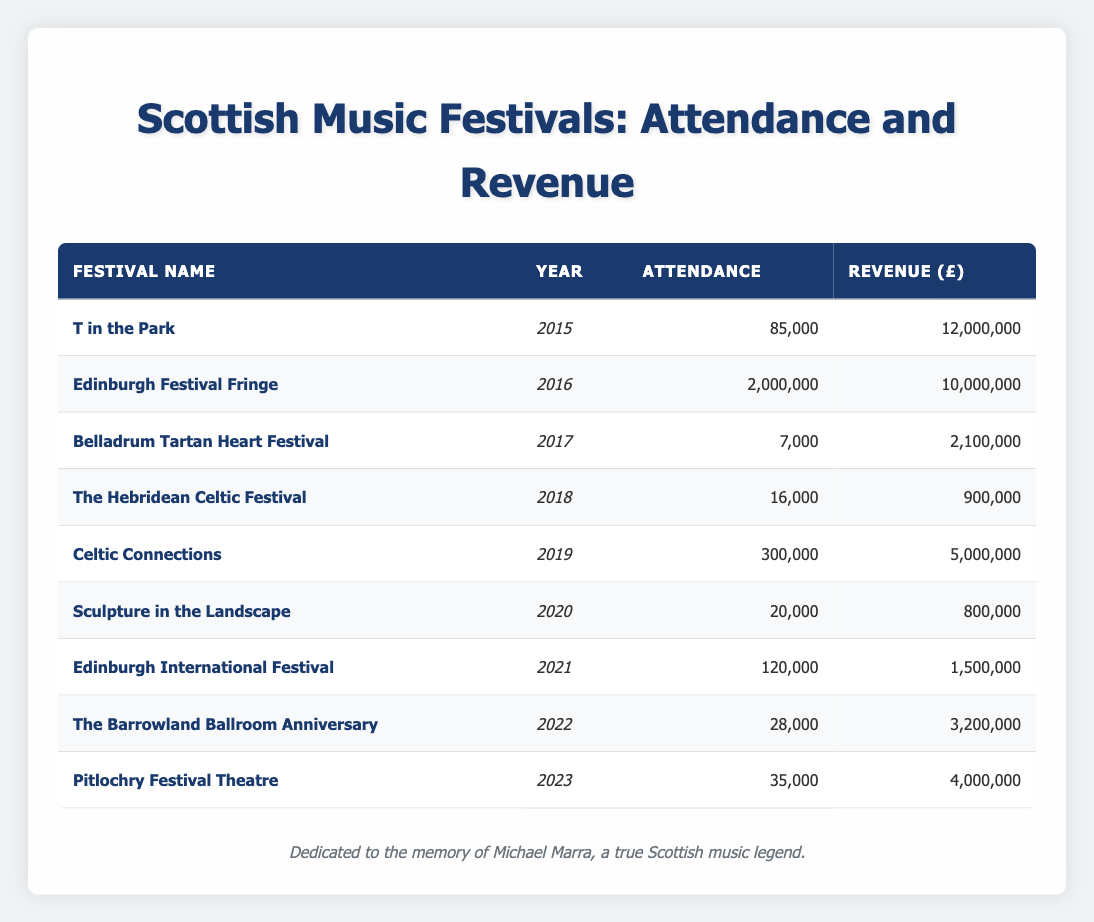What was the attendance at the Edinburgh Festival Fringe in 2016? The attendance for the Edinburgh Festival Fringe in the year 2016 is listed directly in the table, which states it was 2,000,000.
Answer: 2,000,000 Which festival had the highest revenue and what was that revenue? By scanning the revenue column, T in the Park has the highest value of 12,000,000, which is greater than the revenue values of all other festivals.
Answer: 12,000,000 What is the total attendance of all festivals listed from 2015 to 2023? To find the total attendance, I add the attendance of each festival: 85,000 (T in the Park) + 2,000,000 (Edinburgh Festival Fringe) + 7,000 (Belladrum Tartan Heart Festival) + 16,000 (The Hebridean Celtic Festival) + 300,000 (Celtic Connections) + 20,000 (Sculpture in the Landscape) + 120,000 (Edinburgh International Festival) + 28,000 (The Barrowland Ballroom Anniversary) + 35,000 (Pitlochry Festival Theatre) = 2,611,000.
Answer: 2,611,000 Did the attendance for the Pitlochry Festival Theatre increase or decrease compared to the previous year, 2022? The attendance for Pitlochry Festival Theatre in 2023 was 35,000, while the attendance in 2022 for The Barrowland Ballroom Anniversary was 28,000. Since 35,000 is greater than 28,000, it indicates an increase.
Answer: Increase What is the average revenue of all festivals from 2015 to 2023? First, I sum the revenues: 12,000,000 + 10,000,000 + 2,100,000 + 900,000 + 5,000,000 + 800,000 + 1,500,000 + 3,200,000 + 4,000,000 = 39,500,000. There are 9 festivals, so the average revenue is 39,500,000 divided by 9, which equals approximately 4,388,889.
Answer: 4,388,889 Was the revenue of the Hebridean Celtic Festival higher than the revenue of the Sculpture in the Landscape festival? By checking the revenue amounts, the Hebridean Celtic Festival had a revenue of 900,000, while the Sculpture in the Landscape had a revenue of 800,000. Since 900,000 is greater than 800,000, the statement is true.
Answer: Yes What is the difference in attendance between the highest and lowest attended festival? The highest attendance is 2,000,000 (Edinburgh Festival Fringe) and the lowest is 7,000 (Belladrum Tartan Heart Festival). The difference is calculated as 2,000,000 - 7,000 = 1,993,000.
Answer: 1,993,000 